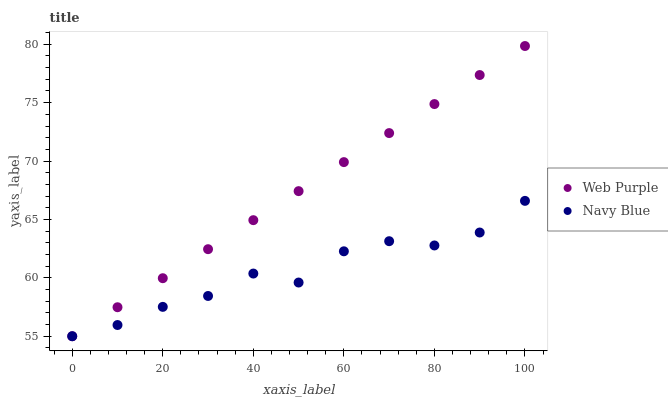Does Navy Blue have the minimum area under the curve?
Answer yes or no. Yes. Does Web Purple have the maximum area under the curve?
Answer yes or no. Yes. Does Web Purple have the minimum area under the curve?
Answer yes or no. No. Is Web Purple the smoothest?
Answer yes or no. Yes. Is Navy Blue the roughest?
Answer yes or no. Yes. Is Web Purple the roughest?
Answer yes or no. No. Does Web Purple have the lowest value?
Answer yes or no. Yes. Does Web Purple have the highest value?
Answer yes or no. Yes. Does Navy Blue intersect Web Purple?
Answer yes or no. Yes. Is Navy Blue less than Web Purple?
Answer yes or no. No. Is Navy Blue greater than Web Purple?
Answer yes or no. No. 